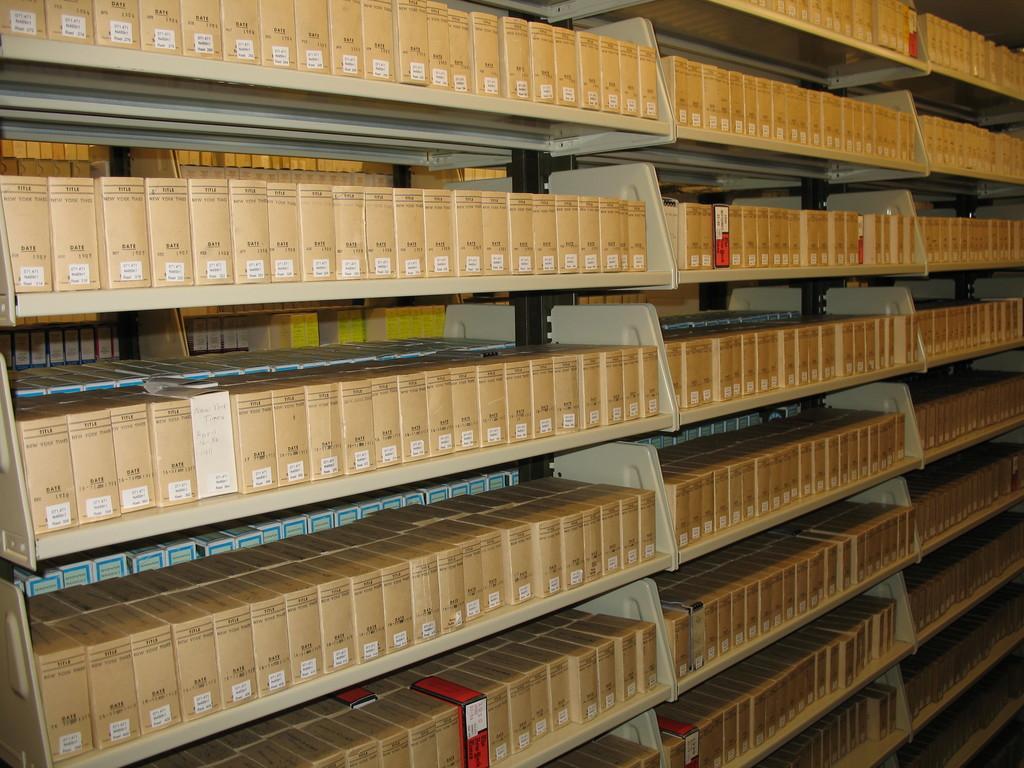Could you give a brief overview of what you see in this image? In this image I can see number of cream colored racks and in the racks I can see number of boxes which are brown in color. I can see few boxes are red and white in color. 